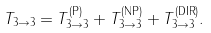Convert formula to latex. <formula><loc_0><loc_0><loc_500><loc_500>T _ { 3 \to 3 } = T _ { 3 \to 3 } ^ { ( \text {P} ) } + T _ { 3 \to 3 } ^ { ( \text {NP} ) } + T _ { 3 \to 3 } ^ { ( \text {DIR} ) } .</formula> 